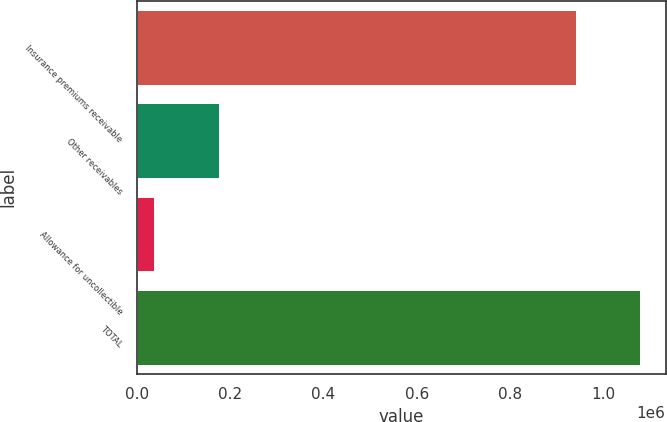Convert chart to OTSL. <chart><loc_0><loc_0><loc_500><loc_500><bar_chart><fcel>Insurance premiums receivable<fcel>Other receivables<fcel>Allowance for uncollectible<fcel>TOTAL<nl><fcel>941460<fcel>175357<fcel>36646<fcel>1.08017e+06<nl></chart> 